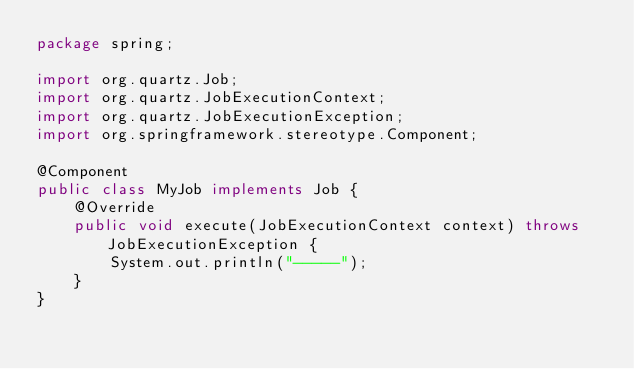<code> <loc_0><loc_0><loc_500><loc_500><_Java_>package spring;

import org.quartz.Job;
import org.quartz.JobExecutionContext;
import org.quartz.JobExecutionException;
import org.springframework.stereotype.Component;

@Component
public class MyJob implements Job {
    @Override
    public void execute(JobExecutionContext context) throws JobExecutionException {
        System.out.println("-----");
    }
}
</code> 